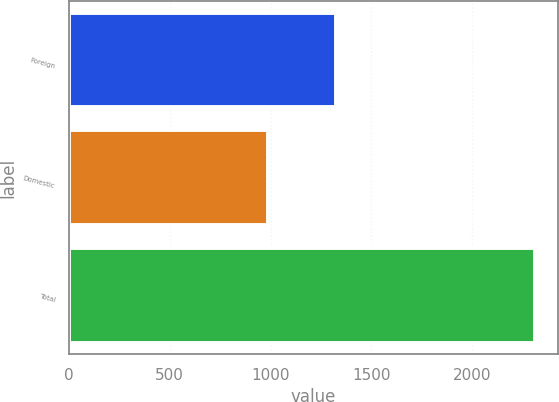Convert chart. <chart><loc_0><loc_0><loc_500><loc_500><bar_chart><fcel>Foreign<fcel>Domestic<fcel>Total<nl><fcel>1327<fcel>985<fcel>2312<nl></chart> 